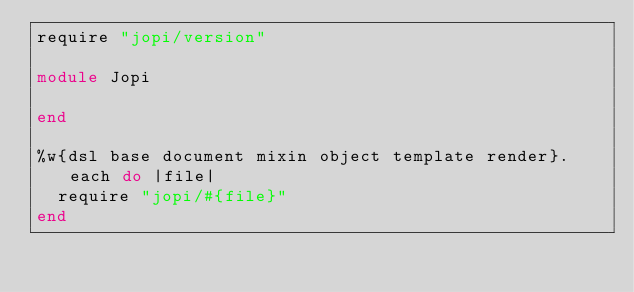<code> <loc_0><loc_0><loc_500><loc_500><_Ruby_>require "jopi/version"

module Jopi

end

%w{dsl base document mixin object template render}.each do |file|
	require "jopi/#{file}"
end
</code> 